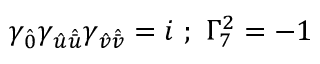Convert formula to latex. <formula><loc_0><loc_0><loc_500><loc_500>\gamma _ { \hat { 0 } } \gamma _ { { \hat { u } } { \hat { \bar { u } } } } \gamma _ { { \hat { v } } { \hat { \bar { v } } } } = i ; \Gamma _ { 7 } ^ { 2 } = - 1</formula> 